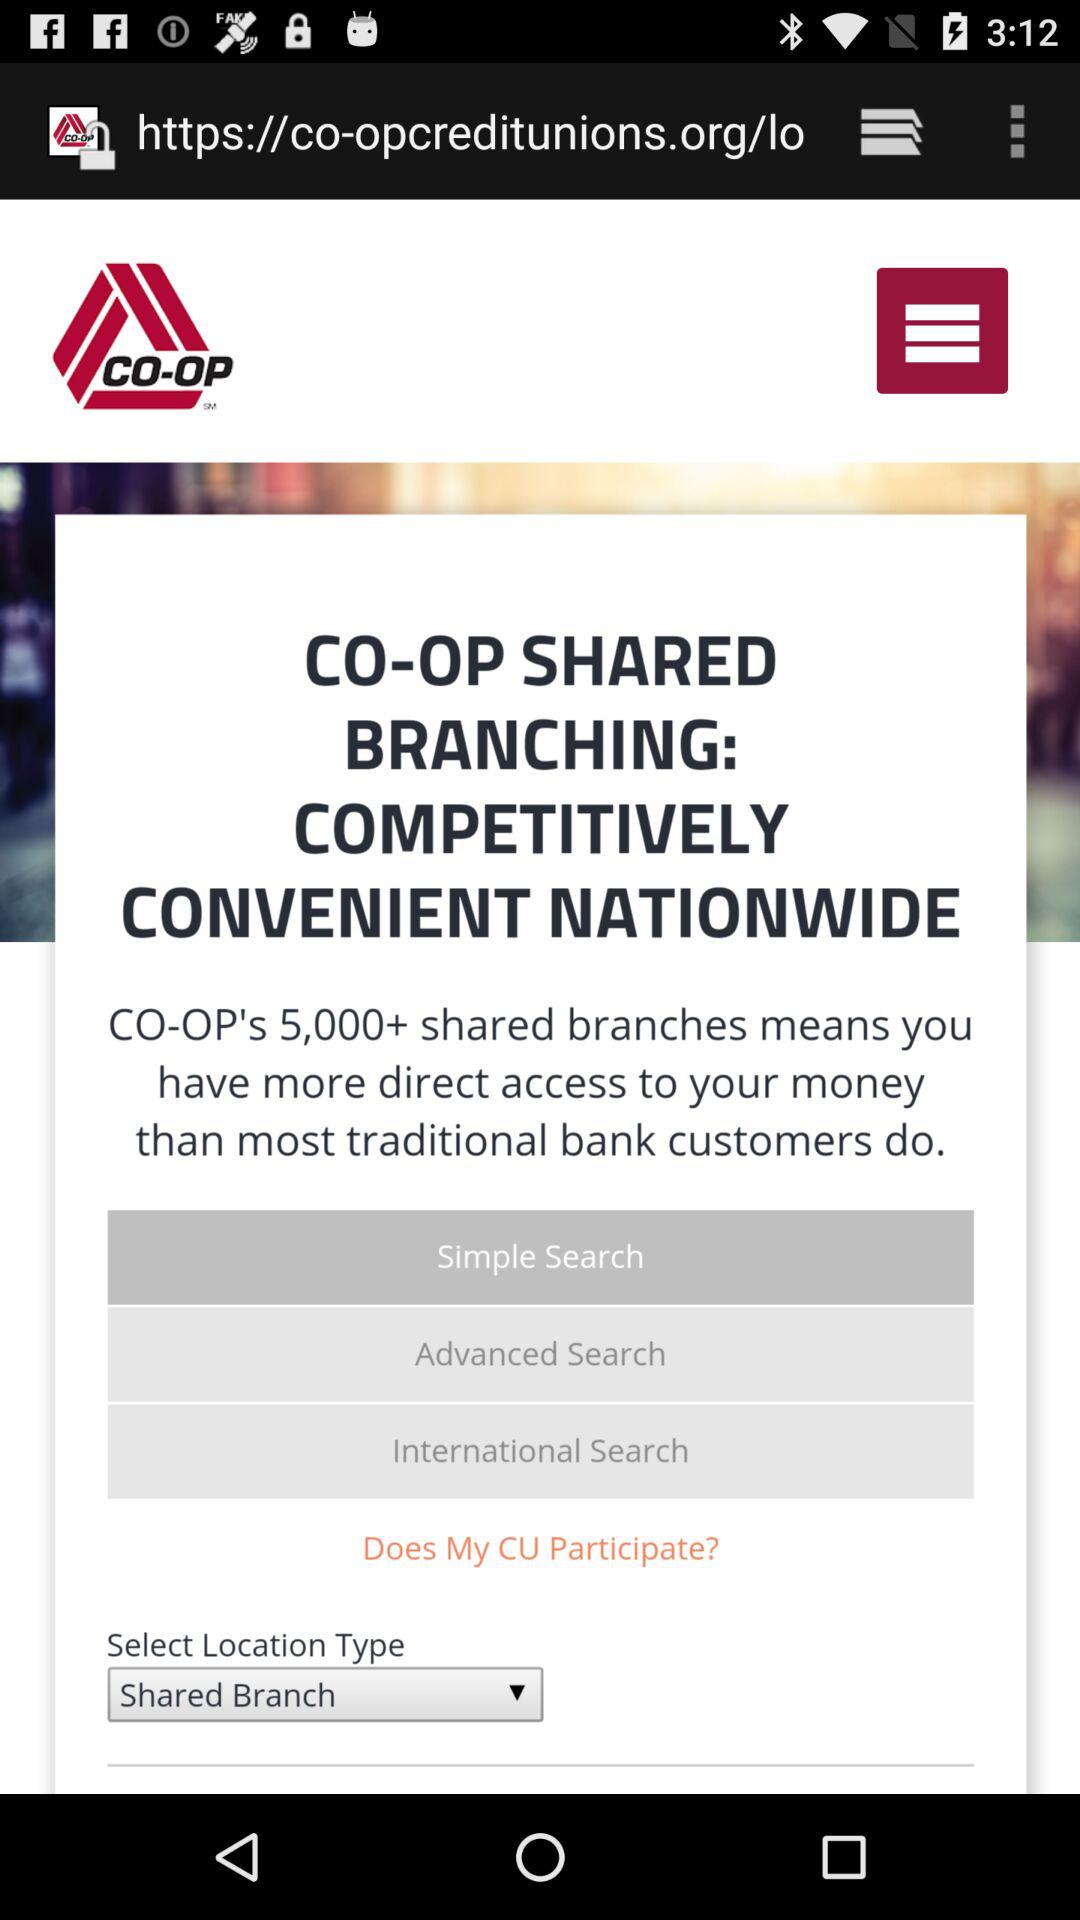What is the app name? The app name is "CO-OP". 